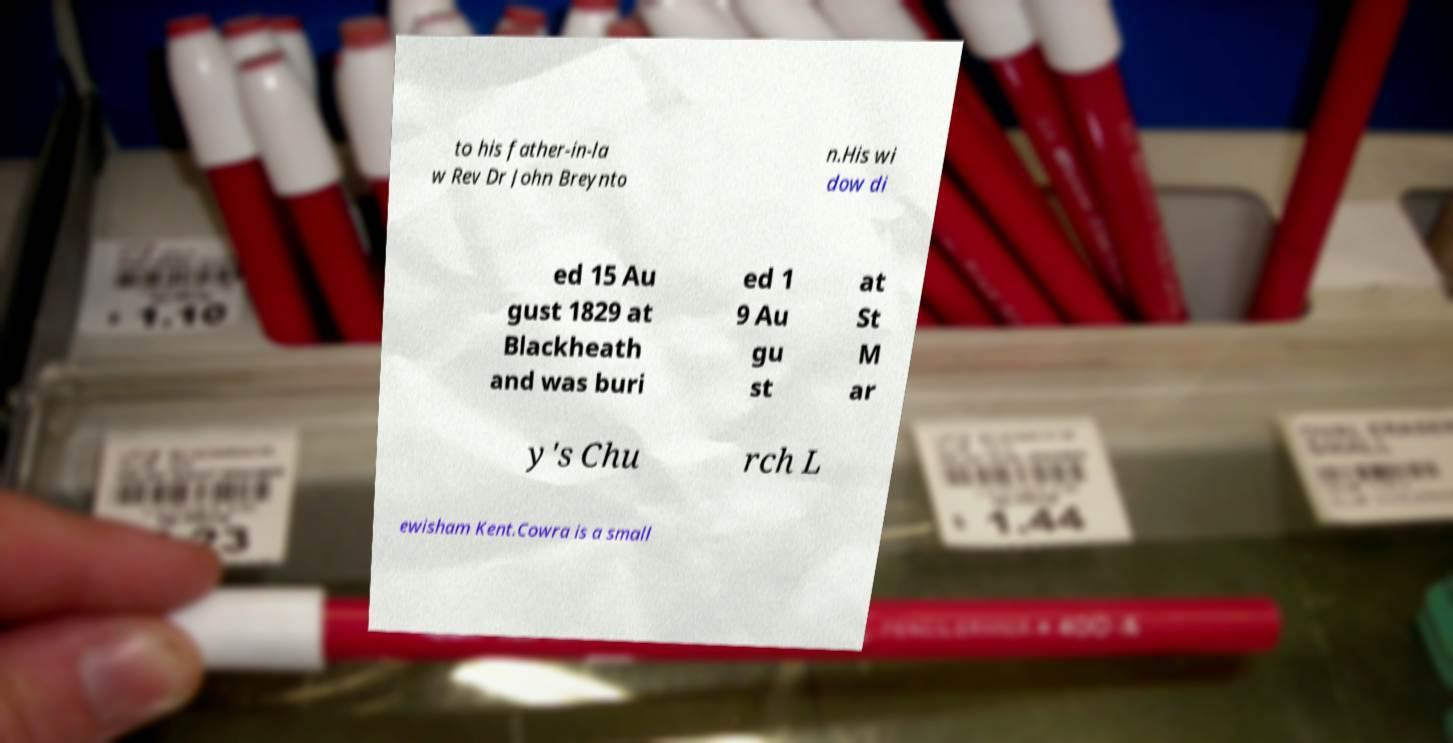Please identify and transcribe the text found in this image. to his father-in-la w Rev Dr John Breynto n.His wi dow di ed 15 Au gust 1829 at Blackheath and was buri ed 1 9 Au gu st at St M ar y's Chu rch L ewisham Kent.Cowra is a small 